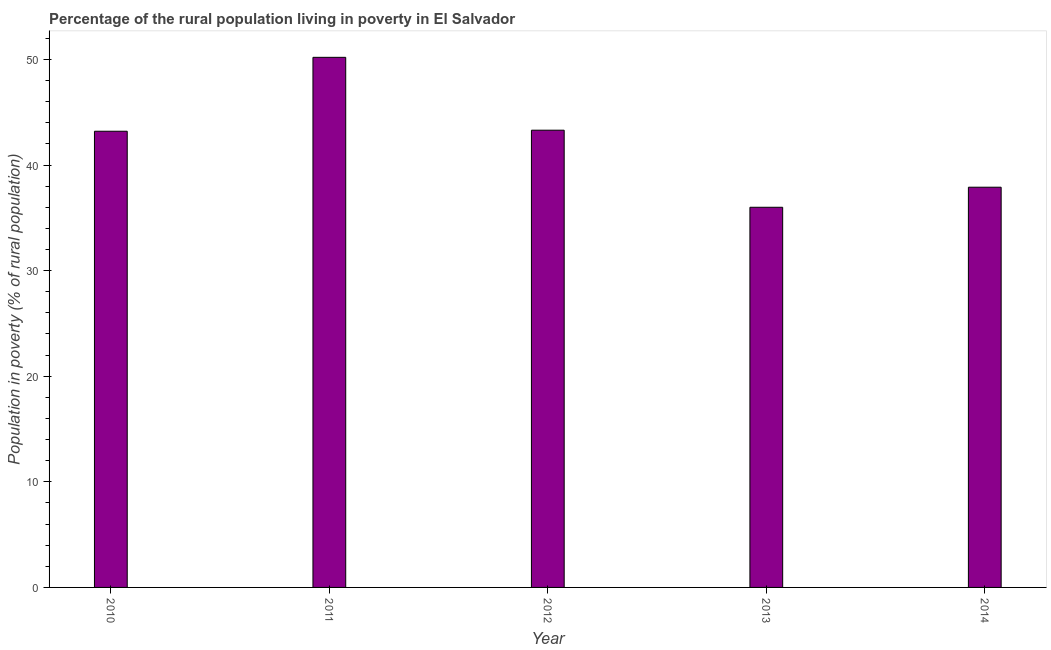Does the graph contain any zero values?
Your response must be concise. No. Does the graph contain grids?
Offer a terse response. No. What is the title of the graph?
Your answer should be compact. Percentage of the rural population living in poverty in El Salvador. What is the label or title of the Y-axis?
Provide a succinct answer. Population in poverty (% of rural population). What is the percentage of rural population living below poverty line in 2010?
Your answer should be compact. 43.2. Across all years, what is the maximum percentage of rural population living below poverty line?
Your response must be concise. 50.2. Across all years, what is the minimum percentage of rural population living below poverty line?
Your answer should be very brief. 36. In which year was the percentage of rural population living below poverty line maximum?
Ensure brevity in your answer.  2011. In which year was the percentage of rural population living below poverty line minimum?
Make the answer very short. 2013. What is the sum of the percentage of rural population living below poverty line?
Your answer should be very brief. 210.6. What is the average percentage of rural population living below poverty line per year?
Your response must be concise. 42.12. What is the median percentage of rural population living below poverty line?
Offer a very short reply. 43.2. Is the percentage of rural population living below poverty line in 2013 less than that in 2014?
Offer a terse response. Yes. Is the difference between the percentage of rural population living below poverty line in 2011 and 2014 greater than the difference between any two years?
Your response must be concise. No. Is the sum of the percentage of rural population living below poverty line in 2010 and 2013 greater than the maximum percentage of rural population living below poverty line across all years?
Keep it short and to the point. Yes. What is the difference between the highest and the lowest percentage of rural population living below poverty line?
Keep it short and to the point. 14.2. In how many years, is the percentage of rural population living below poverty line greater than the average percentage of rural population living below poverty line taken over all years?
Keep it short and to the point. 3. How many years are there in the graph?
Provide a succinct answer. 5. What is the Population in poverty (% of rural population) of 2010?
Your response must be concise. 43.2. What is the Population in poverty (% of rural population) in 2011?
Provide a short and direct response. 50.2. What is the Population in poverty (% of rural population) of 2012?
Your answer should be compact. 43.3. What is the Population in poverty (% of rural population) in 2013?
Your answer should be compact. 36. What is the Population in poverty (% of rural population) in 2014?
Ensure brevity in your answer.  37.9. What is the difference between the Population in poverty (% of rural population) in 2010 and 2013?
Ensure brevity in your answer.  7.2. What is the difference between the Population in poverty (% of rural population) in 2010 and 2014?
Your response must be concise. 5.3. What is the difference between the Population in poverty (% of rural population) in 2012 and 2013?
Keep it short and to the point. 7.3. What is the difference between the Population in poverty (% of rural population) in 2012 and 2014?
Ensure brevity in your answer.  5.4. What is the ratio of the Population in poverty (% of rural population) in 2010 to that in 2011?
Ensure brevity in your answer.  0.86. What is the ratio of the Population in poverty (% of rural population) in 2010 to that in 2013?
Your answer should be very brief. 1.2. What is the ratio of the Population in poverty (% of rural population) in 2010 to that in 2014?
Give a very brief answer. 1.14. What is the ratio of the Population in poverty (% of rural population) in 2011 to that in 2012?
Your answer should be very brief. 1.16. What is the ratio of the Population in poverty (% of rural population) in 2011 to that in 2013?
Provide a succinct answer. 1.39. What is the ratio of the Population in poverty (% of rural population) in 2011 to that in 2014?
Your answer should be very brief. 1.32. What is the ratio of the Population in poverty (% of rural population) in 2012 to that in 2013?
Keep it short and to the point. 1.2. What is the ratio of the Population in poverty (% of rural population) in 2012 to that in 2014?
Your response must be concise. 1.14. What is the ratio of the Population in poverty (% of rural population) in 2013 to that in 2014?
Your response must be concise. 0.95. 